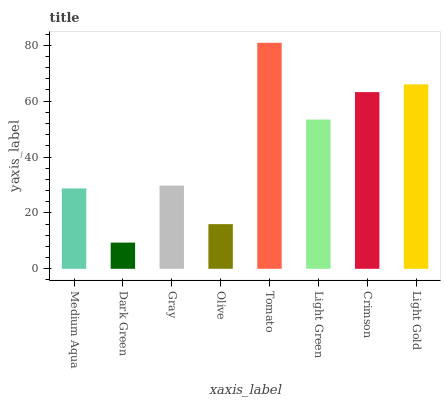Is Dark Green the minimum?
Answer yes or no. Yes. Is Tomato the maximum?
Answer yes or no. Yes. Is Gray the minimum?
Answer yes or no. No. Is Gray the maximum?
Answer yes or no. No. Is Gray greater than Dark Green?
Answer yes or no. Yes. Is Dark Green less than Gray?
Answer yes or no. Yes. Is Dark Green greater than Gray?
Answer yes or no. No. Is Gray less than Dark Green?
Answer yes or no. No. Is Light Green the high median?
Answer yes or no. Yes. Is Gray the low median?
Answer yes or no. Yes. Is Crimson the high median?
Answer yes or no. No. Is Light Gold the low median?
Answer yes or no. No. 